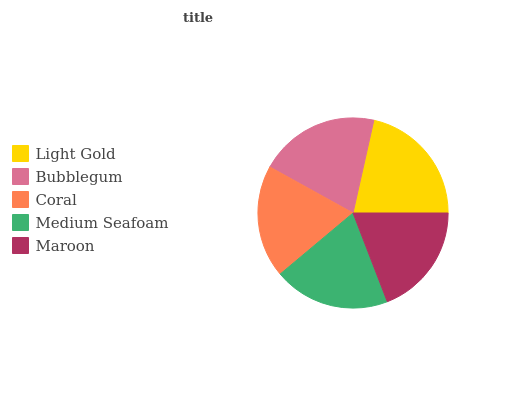Is Maroon the minimum?
Answer yes or no. Yes. Is Light Gold the maximum?
Answer yes or no. Yes. Is Bubblegum the minimum?
Answer yes or no. No. Is Bubblegum the maximum?
Answer yes or no. No. Is Light Gold greater than Bubblegum?
Answer yes or no. Yes. Is Bubblegum less than Light Gold?
Answer yes or no. Yes. Is Bubblegum greater than Light Gold?
Answer yes or no. No. Is Light Gold less than Bubblegum?
Answer yes or no. No. Is Medium Seafoam the high median?
Answer yes or no. Yes. Is Medium Seafoam the low median?
Answer yes or no. Yes. Is Coral the high median?
Answer yes or no. No. Is Coral the low median?
Answer yes or no. No. 